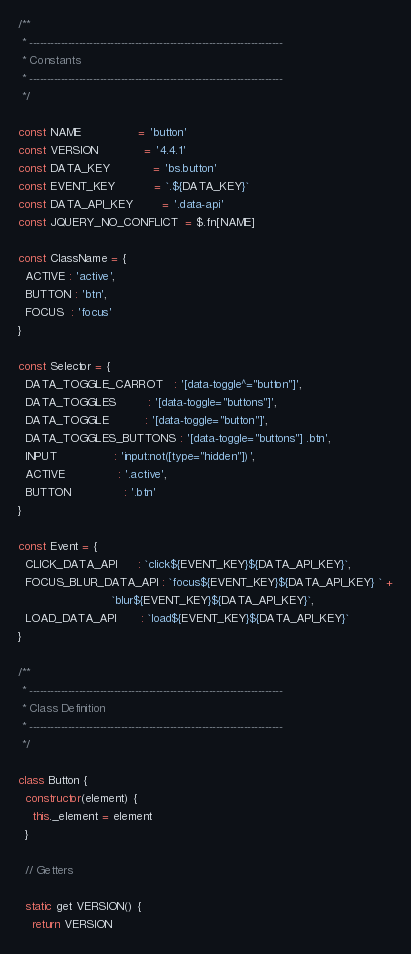Convert code to text. <code><loc_0><loc_0><loc_500><loc_500><_JavaScript_>
/**
 * ------------------------------------------------------------------------
 * Constants
 * ------------------------------------------------------------------------
 */

const NAME                = 'button'
const VERSION             = '4.4.1'
const DATA_KEY            = 'bs.button'
const EVENT_KEY           = `.${DATA_KEY}`
const DATA_API_KEY        = '.data-api'
const JQUERY_NO_CONFLICT  = $.fn[NAME]

const ClassName = {
  ACTIVE : 'active',
  BUTTON : 'btn',
  FOCUS  : 'focus'
}

const Selector = {
  DATA_TOGGLE_CARROT   : '[data-toggle^="button"]',
  DATA_TOGGLES         : '[data-toggle="buttons"]',
  DATA_TOGGLE          : '[data-toggle="button"]',
  DATA_TOGGLES_BUTTONS : '[data-toggle="buttons"] .btn',
  INPUT                : 'input:not([type="hidden"])',
  ACTIVE               : '.active',
  BUTTON               : '.btn'
}

const Event = {
  CLICK_DATA_API      : `click${EVENT_KEY}${DATA_API_KEY}`,
  FOCUS_BLUR_DATA_API : `focus${EVENT_KEY}${DATA_API_KEY} ` +
                          `blur${EVENT_KEY}${DATA_API_KEY}`,
  LOAD_DATA_API       : `load${EVENT_KEY}${DATA_API_KEY}`
}

/**
 * ------------------------------------------------------------------------
 * Class Definition
 * ------------------------------------------------------------------------
 */

class Button {
  constructor(element) {
    this._element = element
  }

  // Getters

  static get VERSION() {
    return VERSION</code> 